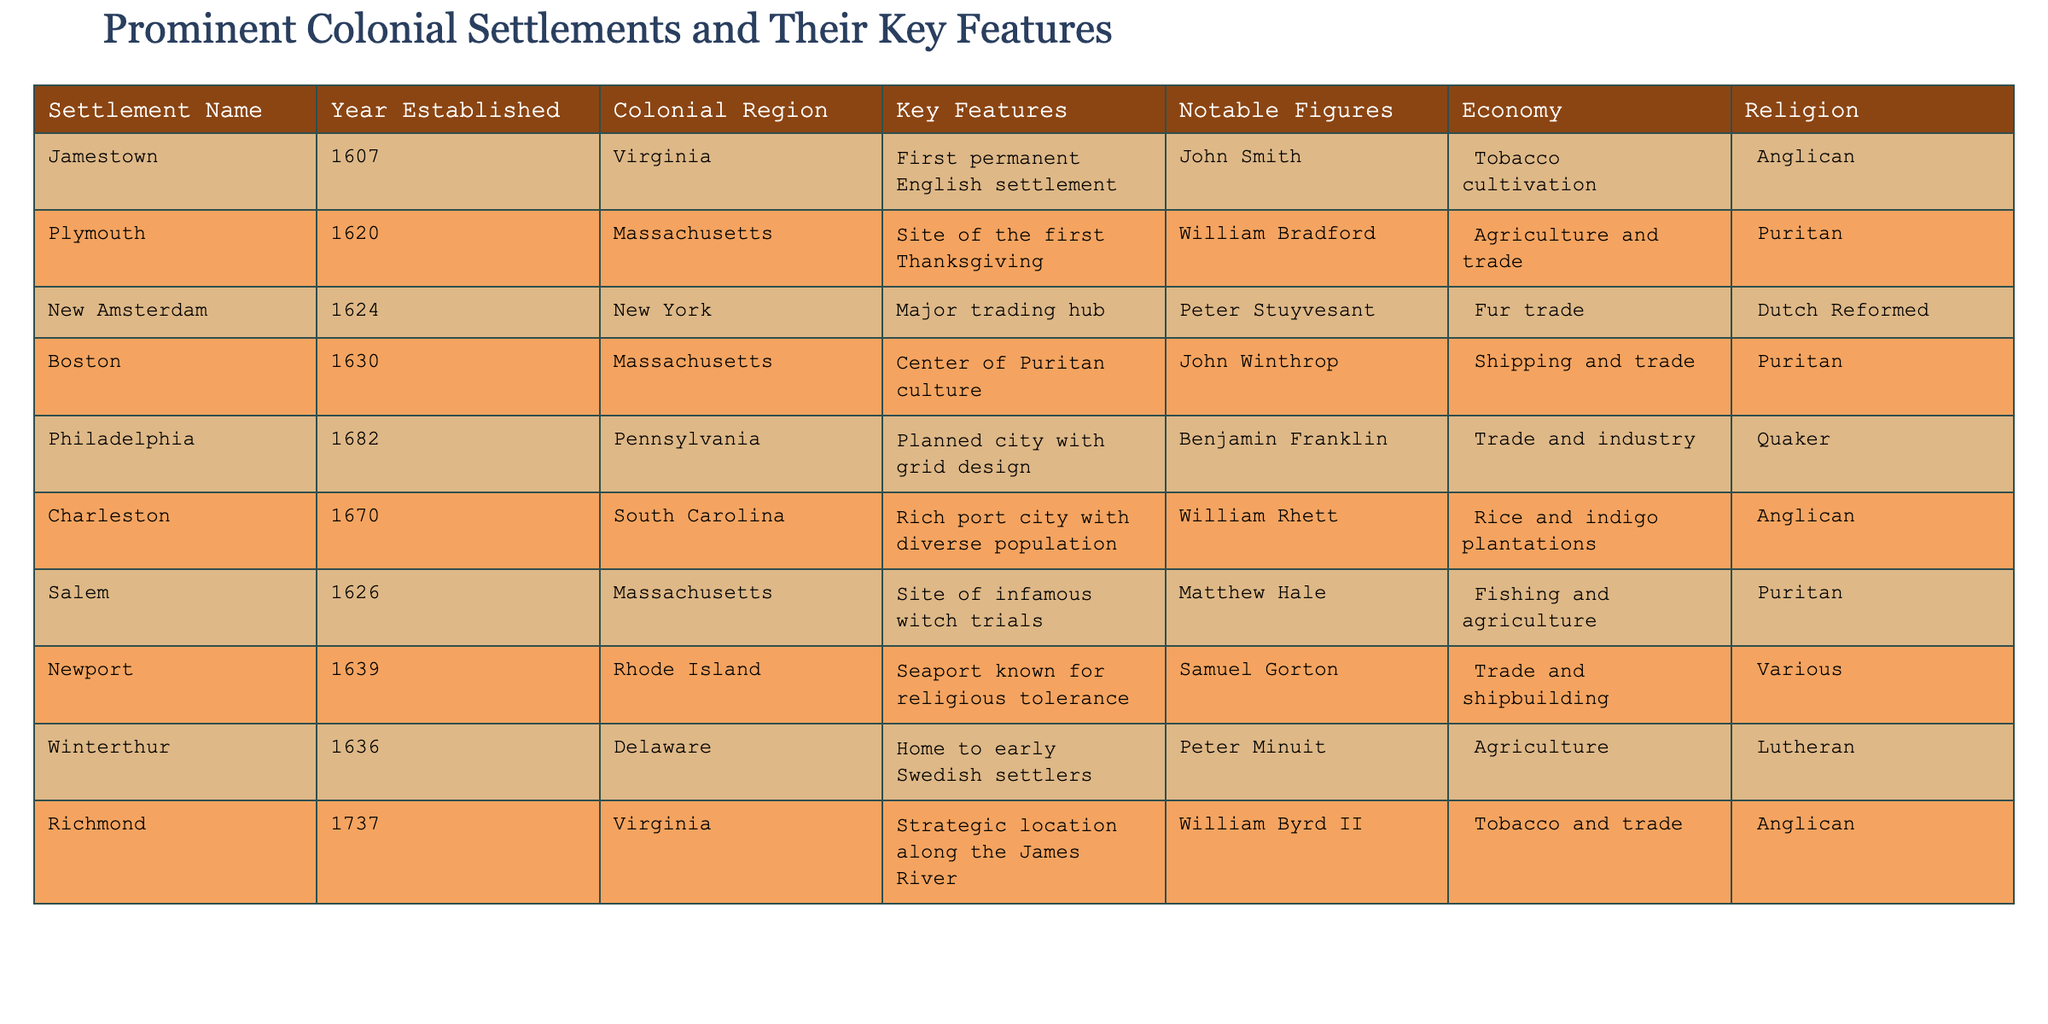What is the year established for Jamestown? The table lists "Jamestown" under the "Settlement Name" column and shows "1607" under the "Year Established" column next to it.
Answer: 1607 Which settlement is known for being the site of the first Thanksgiving? The table indicates that "Plymouth" is the settlement with the key feature of being the "Site of the first Thanksgiving."
Answer: Plymouth True or False: Philadelphia is known for its agricultural economy. In the table, the "Economy" column for "Philadelphia" states "Trade and industry." Therefore, the statement about agriculture is incorrect.
Answer: False How many colonial settlements have a Puritan religious affiliation? By going through the "Religion" column, we find "Puritan" listed for Plymouth, Boston, and Salem, totaling three settlements.
Answer: 3 Which colonial settlement has tobacco cultivation as its primary economy? The settlement "Jamestown" in the table under the "Economy" column mentions "Tobacco cultivation."
Answer: Jamestown What is the relationship between the year established and the economy type for the oldest settlement, Jamestown? Jamestown was established in 1607 and has "Tobacco cultivation" as its economy. This illustrates that early settlements often relied on cash crops for economic sustainability.
Answer: 1607, Tobacco cultivation List all settlements established in the 1600s that were located in Massachusetts. The table lists "Plymouth" (1620), "Boston" (1630), and "Salem" (1626) under Massachusetts, showing that all three were established in the 1600s.
Answer: Plymouth, Boston, Salem Which settlement is identified as a major trading hub and when was it established? New Amsterdam is mentioned as a "Major trading hub" in the table, established in "1624."
Answer: New Amsterdam, 1624 How does the economy of Charleston compare to that of Richmond? Charleston's economy is described as "Rice and indigo plantations," while Richmond's economy focuses on "Tobacco and trade." Both settlements engage in agriculture but specialize in different crops.
Answer: Different crops, both agricultural 